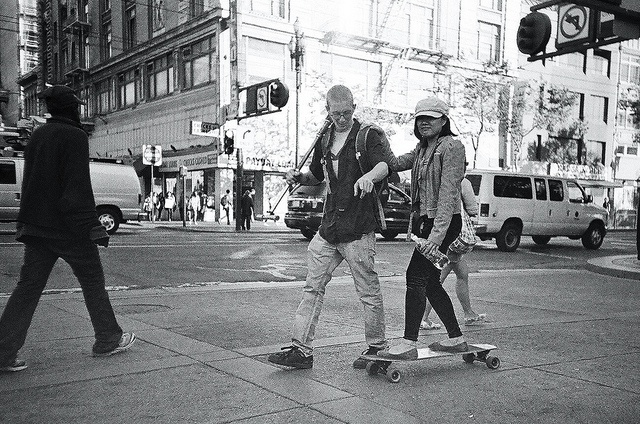Describe the objects in this image and their specific colors. I can see people in gray, black, darkgray, and lightgray tones, people in gray, darkgray, black, and lightgray tones, people in gray, black, darkgray, and lightgray tones, car in gray, black, darkgray, and lightgray tones, and car in gray, darkgray, black, and lightgray tones in this image. 